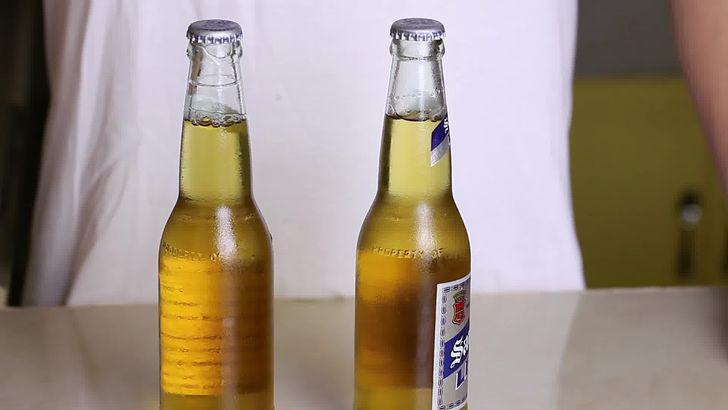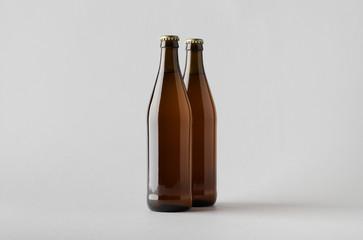The first image is the image on the left, the second image is the image on the right. Evaluate the accuracy of this statement regarding the images: "In one image there is one green bottle with one brown bottle". Is it true? Answer yes or no. No. The first image is the image on the left, the second image is the image on the right. For the images shown, is this caption "An image shows exactly two bottles, one of them green." true? Answer yes or no. No. The first image is the image on the left, the second image is the image on the right. For the images shown, is this caption "There is a green bottle in one of the images." true? Answer yes or no. No. The first image is the image on the left, the second image is the image on the right. Examine the images to the left and right. Is the description "There is exactly one green bottle in one of the images." accurate? Answer yes or no. No. 